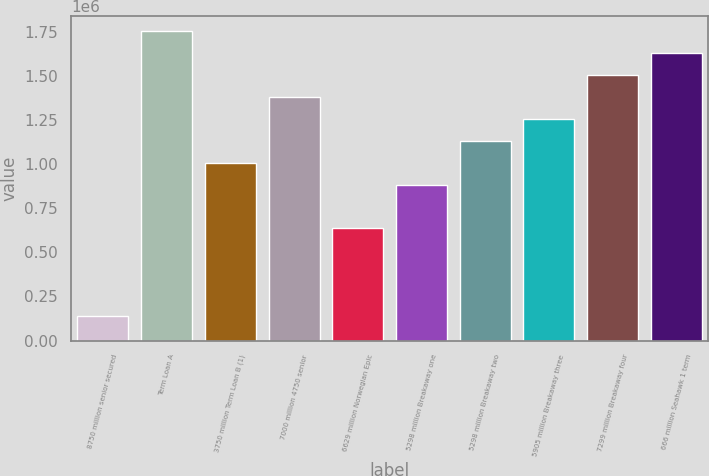<chart> <loc_0><loc_0><loc_500><loc_500><bar_chart><fcel>8750 million senior secured<fcel>Term Loan A<fcel>3750 million Term Loan B (1)<fcel>7000 million 4750 senior<fcel>6629 million Norwegian Epic<fcel>5298 million Breakaway one<fcel>5298 million Breakaway two<fcel>5905 million Breakaway three<fcel>7299 million Breakaway four<fcel>666 million Seahawk 1 term<nl><fcel>138087<fcel>1.75309e+06<fcel>1.0077e+06<fcel>1.3804e+06<fcel>635012<fcel>883474<fcel>1.13194e+06<fcel>1.25617e+06<fcel>1.50463e+06<fcel>1.62886e+06<nl></chart> 